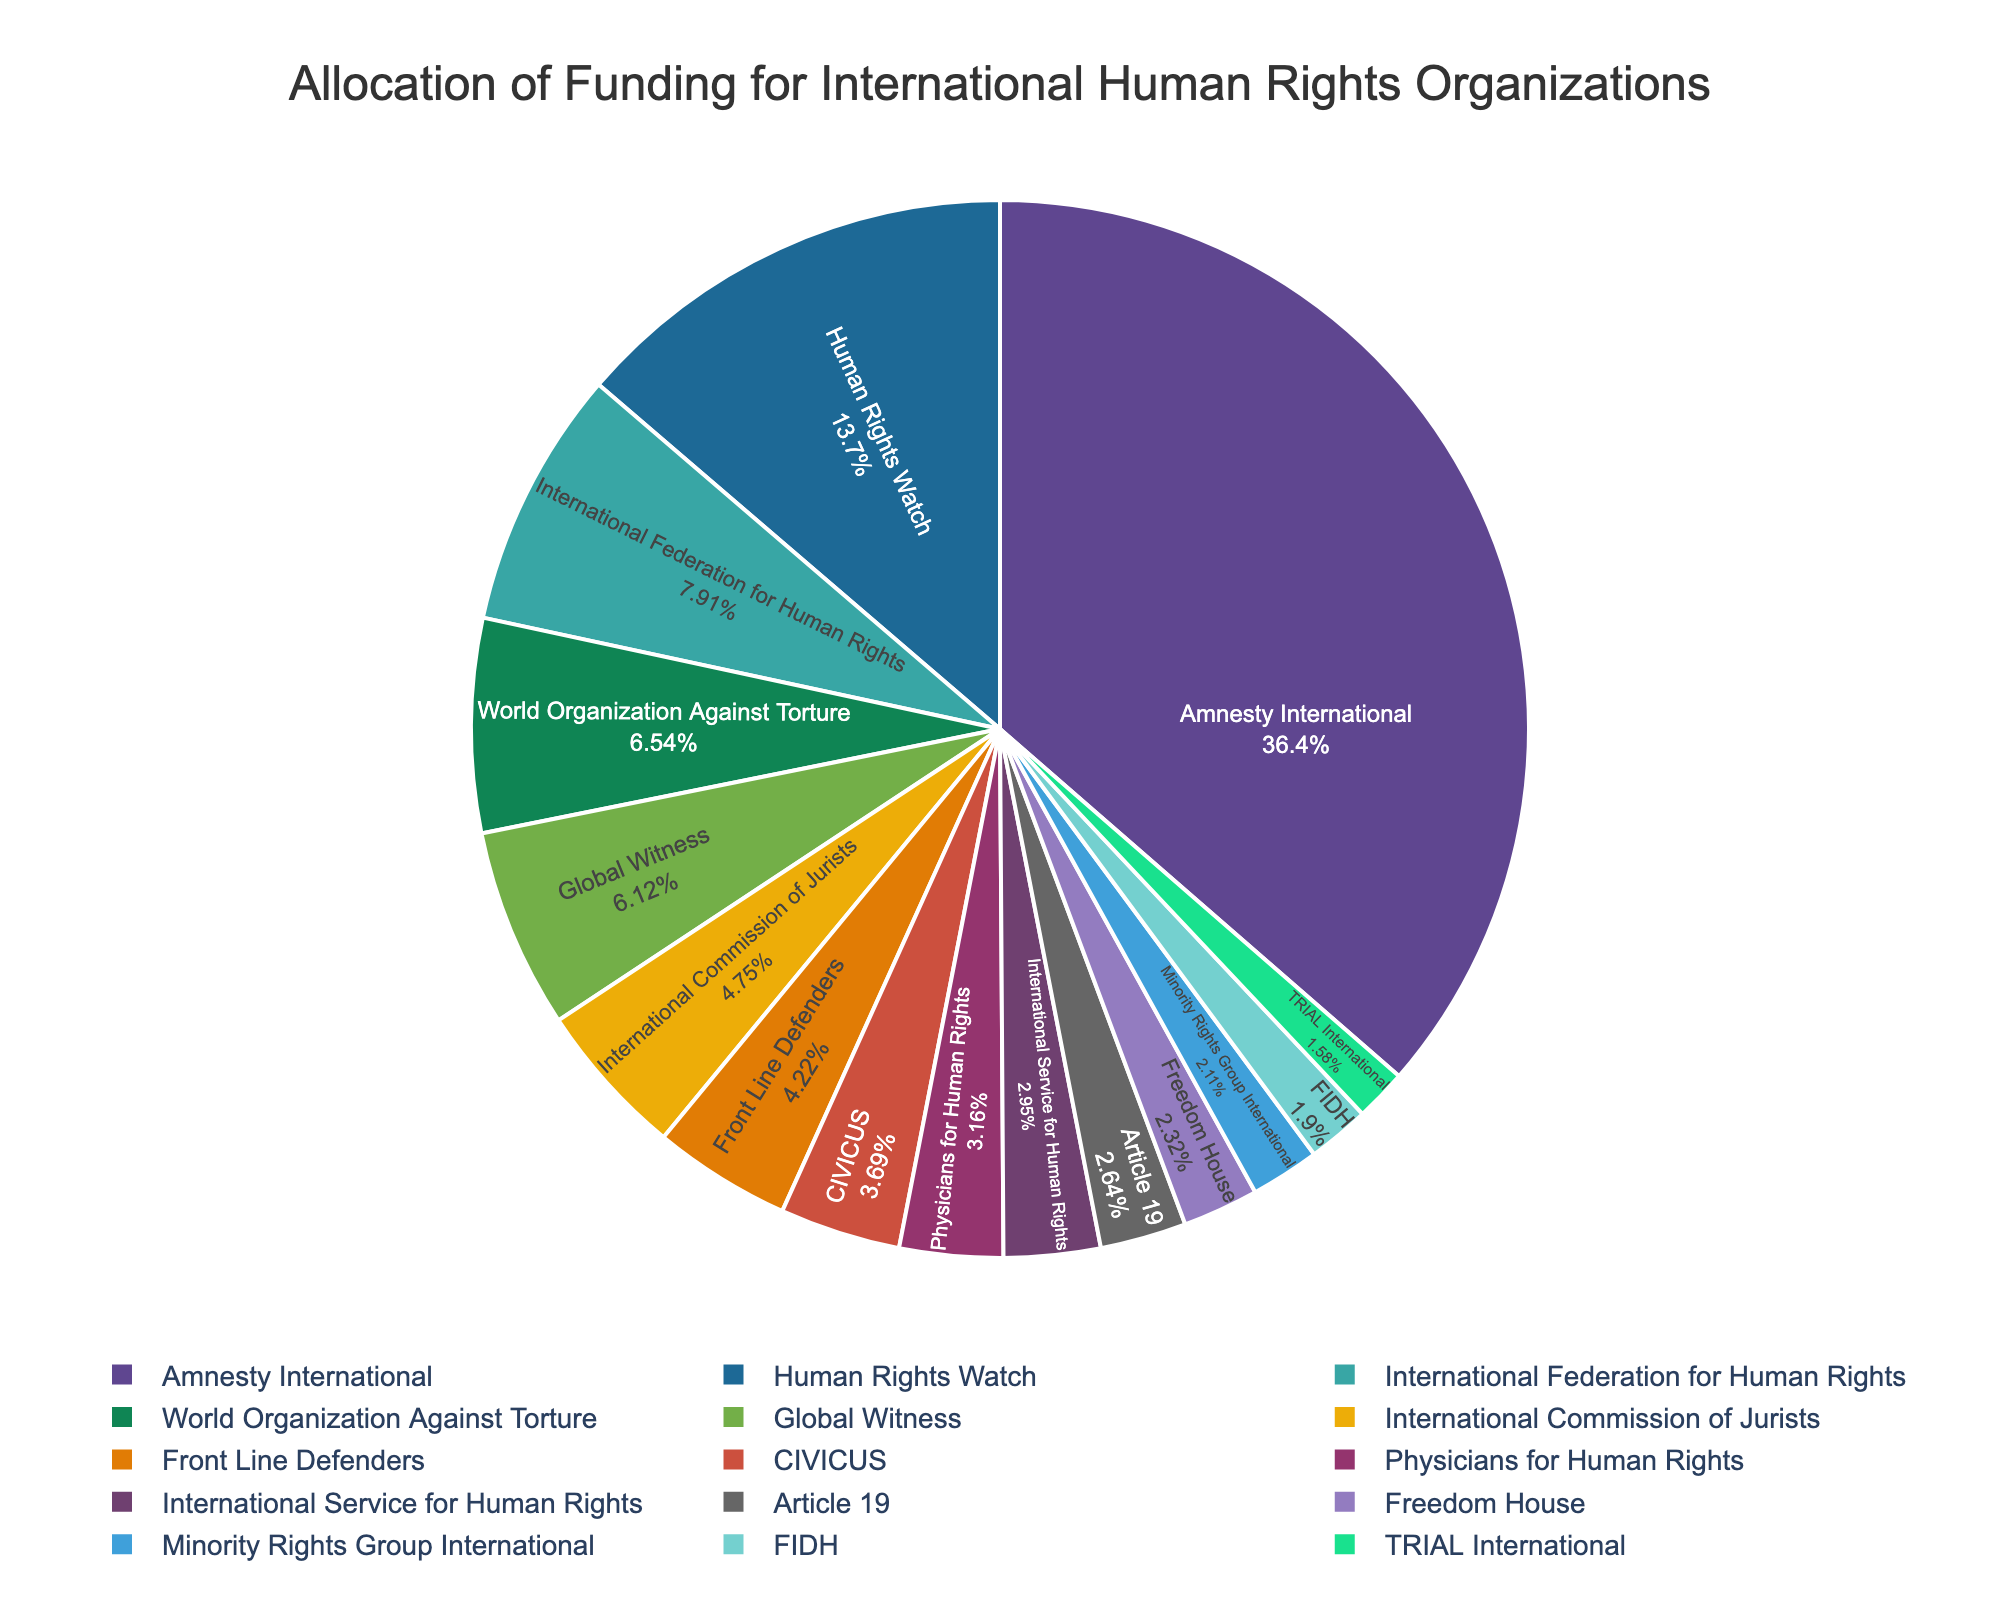What percentage of the total funding does Amnesty International receive? To find the percentage of funding allocated to Amnesty International, divide its funding by the total funding amount for all organizations and multiply by 100. Amnesty International receives $345 million, and the total funding is $948 million. So, (345 / 948) * 100 = 36.39%.
Answer: 36.39% Which organization receives the least amount of funding? To determine which organization receives the least funding, look for the smallest segment in the pie chart. TRIAL International receives the least funding with $15 million.
Answer: TRIAL International How much more funding does Amnesty International receive compared to Human Rights Watch? To calculate the difference in funding between Amnesty International and Human Rights Watch, subtract the funding amount of Human Rights Watch from that of Amnesty International. Amnesty International receives $345 million, and Human Rights Watch receives $130 million. So, 345 - 130 = 215 million.
Answer: 215 million Which organization receives more funding: Global Witness or Physicians for Human Rights? To compare the funding of Global Witness and Physicians for Human Rights, look at the pie chart segments for each. Global Witness receives $58 million, while Physicians for Human Rights receives $30 million.
Answer: Global Witness What is the combined funding of International Federation for Human Rights and World Organization Against Torture? Add the funding amounts of International Federation for Human Rights and World Organization Against Torture. International Federation for Human Rights receives $75 million, and World Organization Against Torture receives $62 million. So, 75 + 62 = 137 million.
Answer: 137 million How many organizations receive funding amounts greater than $50 million? Identify the segments in the pie chart representing funding amounts greater than $50 million and count them. Amnesty International, Human Rights Watch, International Federation for Human Rights, and World Organization Against Torture all receive greater than $50 million.
Answer: 4 Is the funding allocation for CIVICUS more or less than that for Freedom House? Compare the segments for CIVICUS and Freedom House in the pie chart. CIVICUS receives $35 million, while Freedom House receives $22 million.
Answer: More Which three organizations receive the highest funding? Identify the three largest segments in the pie chart. The organizations receiving the highest funding are Amnesty International ($345 million), Human Rights Watch ($130 million), and International Federation for Human Rights ($75 million).
Answer: Amnesty International, Human Rights Watch, International Federation for Human Rights What proportion of the total funding is allocated to minority-focused organizations (e.g., Minority Rights Group International)? Calculate the percentage of total funding allocated to Minority Rights Group International by dividing its funding by the total funding and multiplying by 100. Minority Rights Group International receives $20 million, and the total funding is $948 million. So, (20 / 948) * 100 = 2.11%.
Answer: 2.11% 